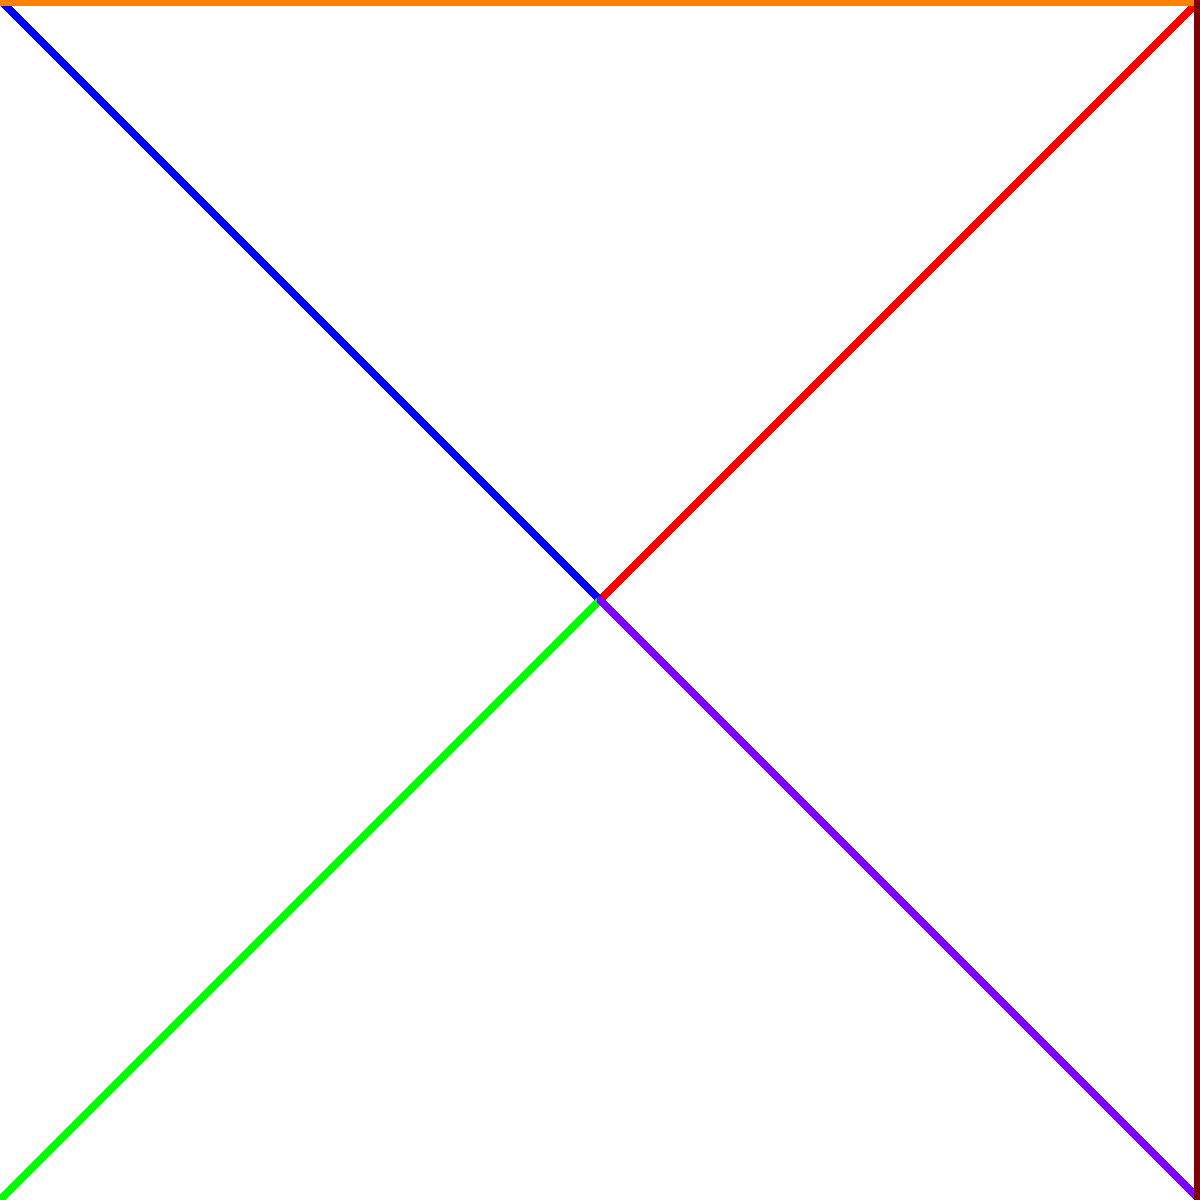In the context of the Hundred Years' War, examine the graph depicting the complex alliances and conflicts between England and various European powers. Which power, represented by a vertex in the graph, had the most significant impact on the balance of power, and how does this reflect the intricate web of relationships during this tumultuous period of English and European history? To answer this question, we must carefully analyze the graph and consider the historical context of the Hundred Years' War:

1. Vertices: The graph shows five key players: England, France, Scotland, Flanders, and Burgundy.

2. Edges: Green lines represent alliances, while red lines represent conflicts.

3. England's connections:
   a. Conflict with France (primary adversary)
   b. Conflict with Scotland (traditional enemy)
   c. Alliance with Flanders (important trade partner)
   d. Alliance with Burgundy (strategic continental ally)

4. France's additional connections:
   a. Alliance with Scotland (Auld Alliance)
   b. Conflict with Burgundy

5. Analyzing the impact:
   a. France has the most connections (4), indicating its central role.
   b. France is involved in conflicts with England and Burgundy, and an alliance with Scotland.
   c. France's position affects all other powers directly or indirectly.

6. Historical context:
   a. The war was primarily between England and France for control of the French throne.
   b. Scotland's alliance with France (Auld Alliance) forced England to divide its attention.
   c. Flanders and Burgundy were crucial for England's continental strategy and trade.

7. Balance of power:
   a. France's central position allowed it to influence or be influenced by all other powers.
   b. France's ability to maintain the Scottish alliance while contesting English claims was crucial.
   c. France's conflict with Burgundy added complexity to the war's later stages.

Given these factors, France emerges as the power with the most significant impact on the balance of power during the Hundred Years' War. Its central position in the graph reflects its pivotal role in the conflict, its ability to form alliances, and its direct opposition to England's ambitions.
Answer: France 